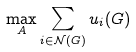<formula> <loc_0><loc_0><loc_500><loc_500>\max _ { A } { \sum _ { i \in \mathcal { N } ( G ) } u _ { i } ( G ) }</formula> 